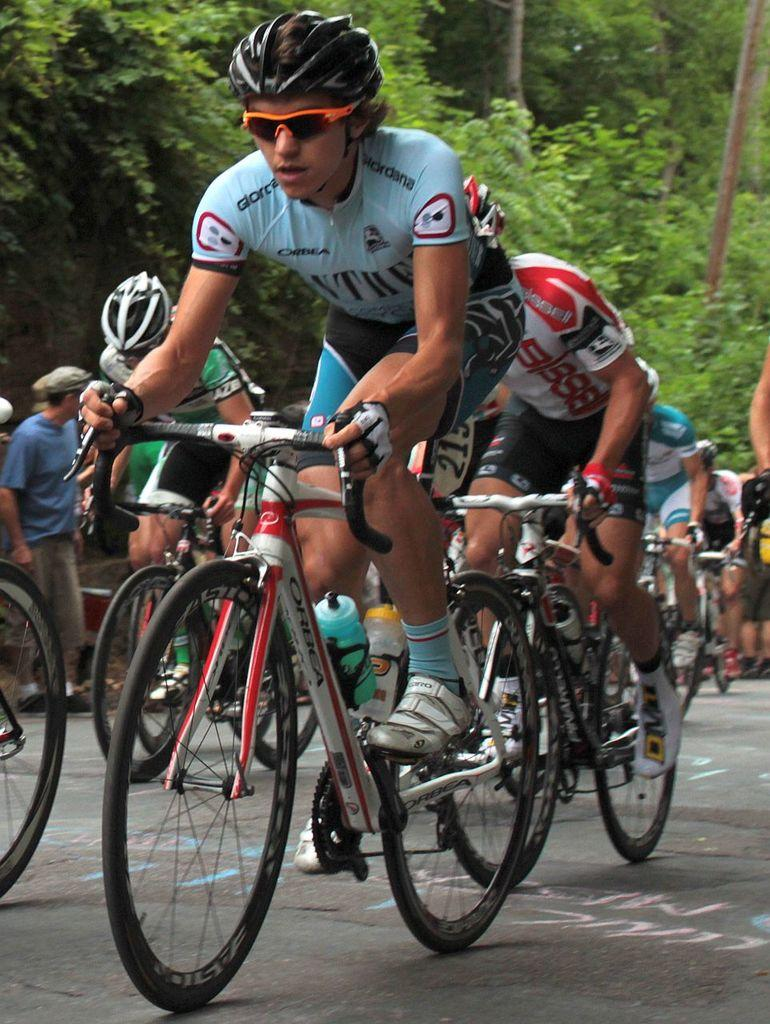What are the people in the image doing? The people in the image are riding bicycles. What can be seen in the background of the image? There are trees in the background of the image. Can you describe the person on the left side of the image? There is a person standing on the left side of the image. What type of beef is being served at the picnic in the image? There is no picnic or beef present in the image; it features people riding bicycles and trees in the background. 